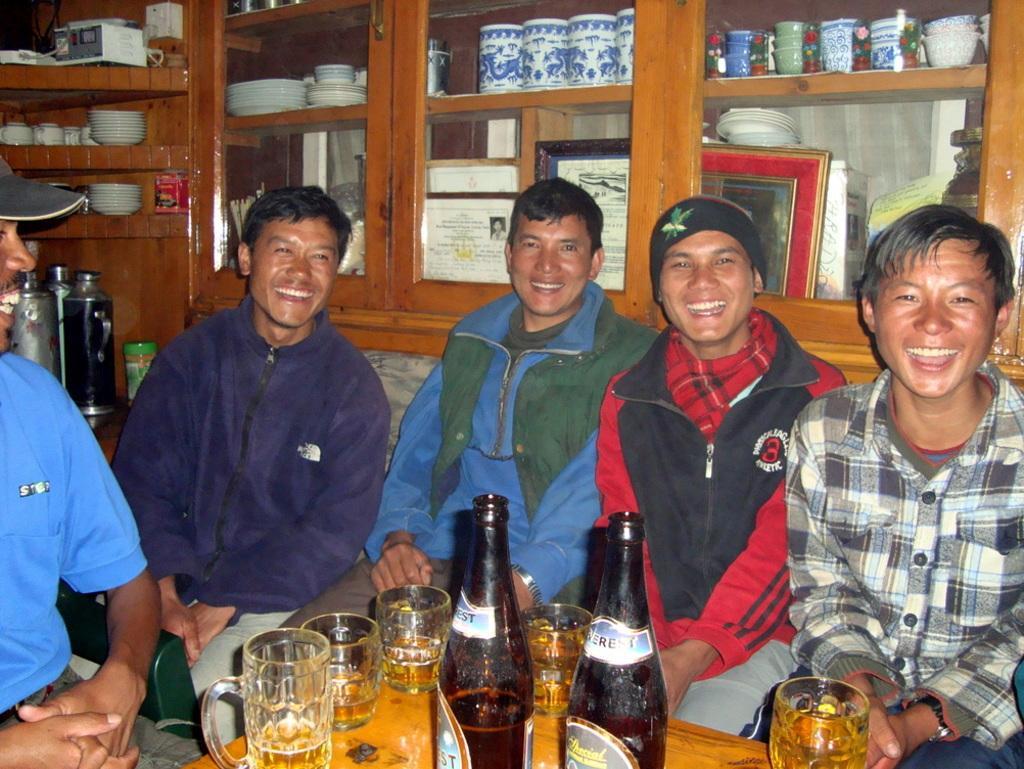Could you give a brief overview of what you see in this image? In this image there are five people sitting on the couch. On the table there is a bottle and a glasses. At the back side there is cupboard. In the cupboard there are plates,frames,bowls and some objects. 